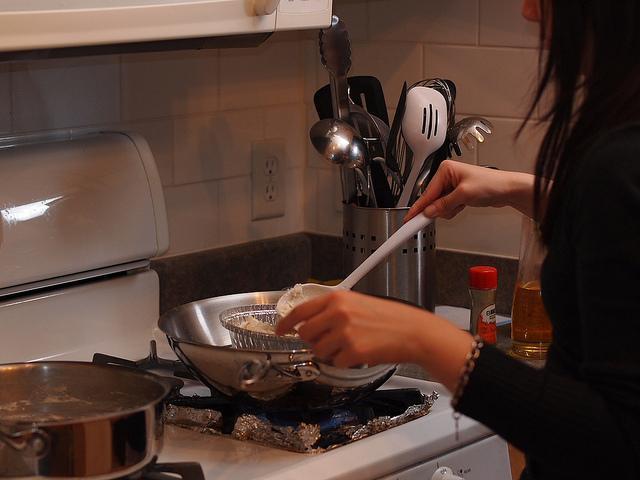How many spoons are in the photo?
Give a very brief answer. 3. How many bottles can be seen?
Give a very brief answer. 2. How many cars face the bus?
Give a very brief answer. 0. 